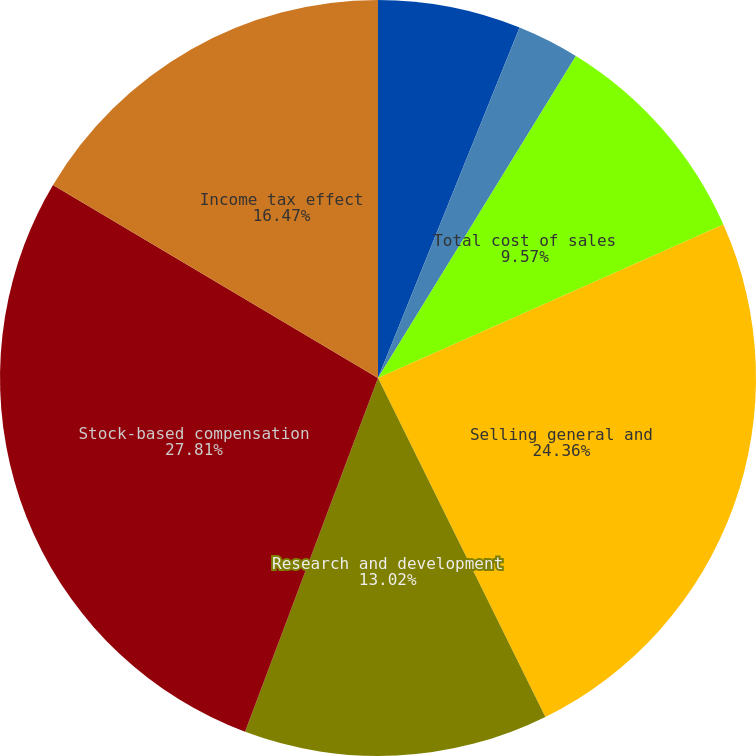<chart> <loc_0><loc_0><loc_500><loc_500><pie_chart><fcel>Cost of sales-products<fcel>Cost of sales-services<fcel>Total cost of sales<fcel>Selling general and<fcel>Research and development<fcel>Stock-based compensation<fcel>Income tax effect<nl><fcel>6.11%<fcel>2.66%<fcel>9.57%<fcel>24.36%<fcel>13.02%<fcel>27.81%<fcel>16.47%<nl></chart> 